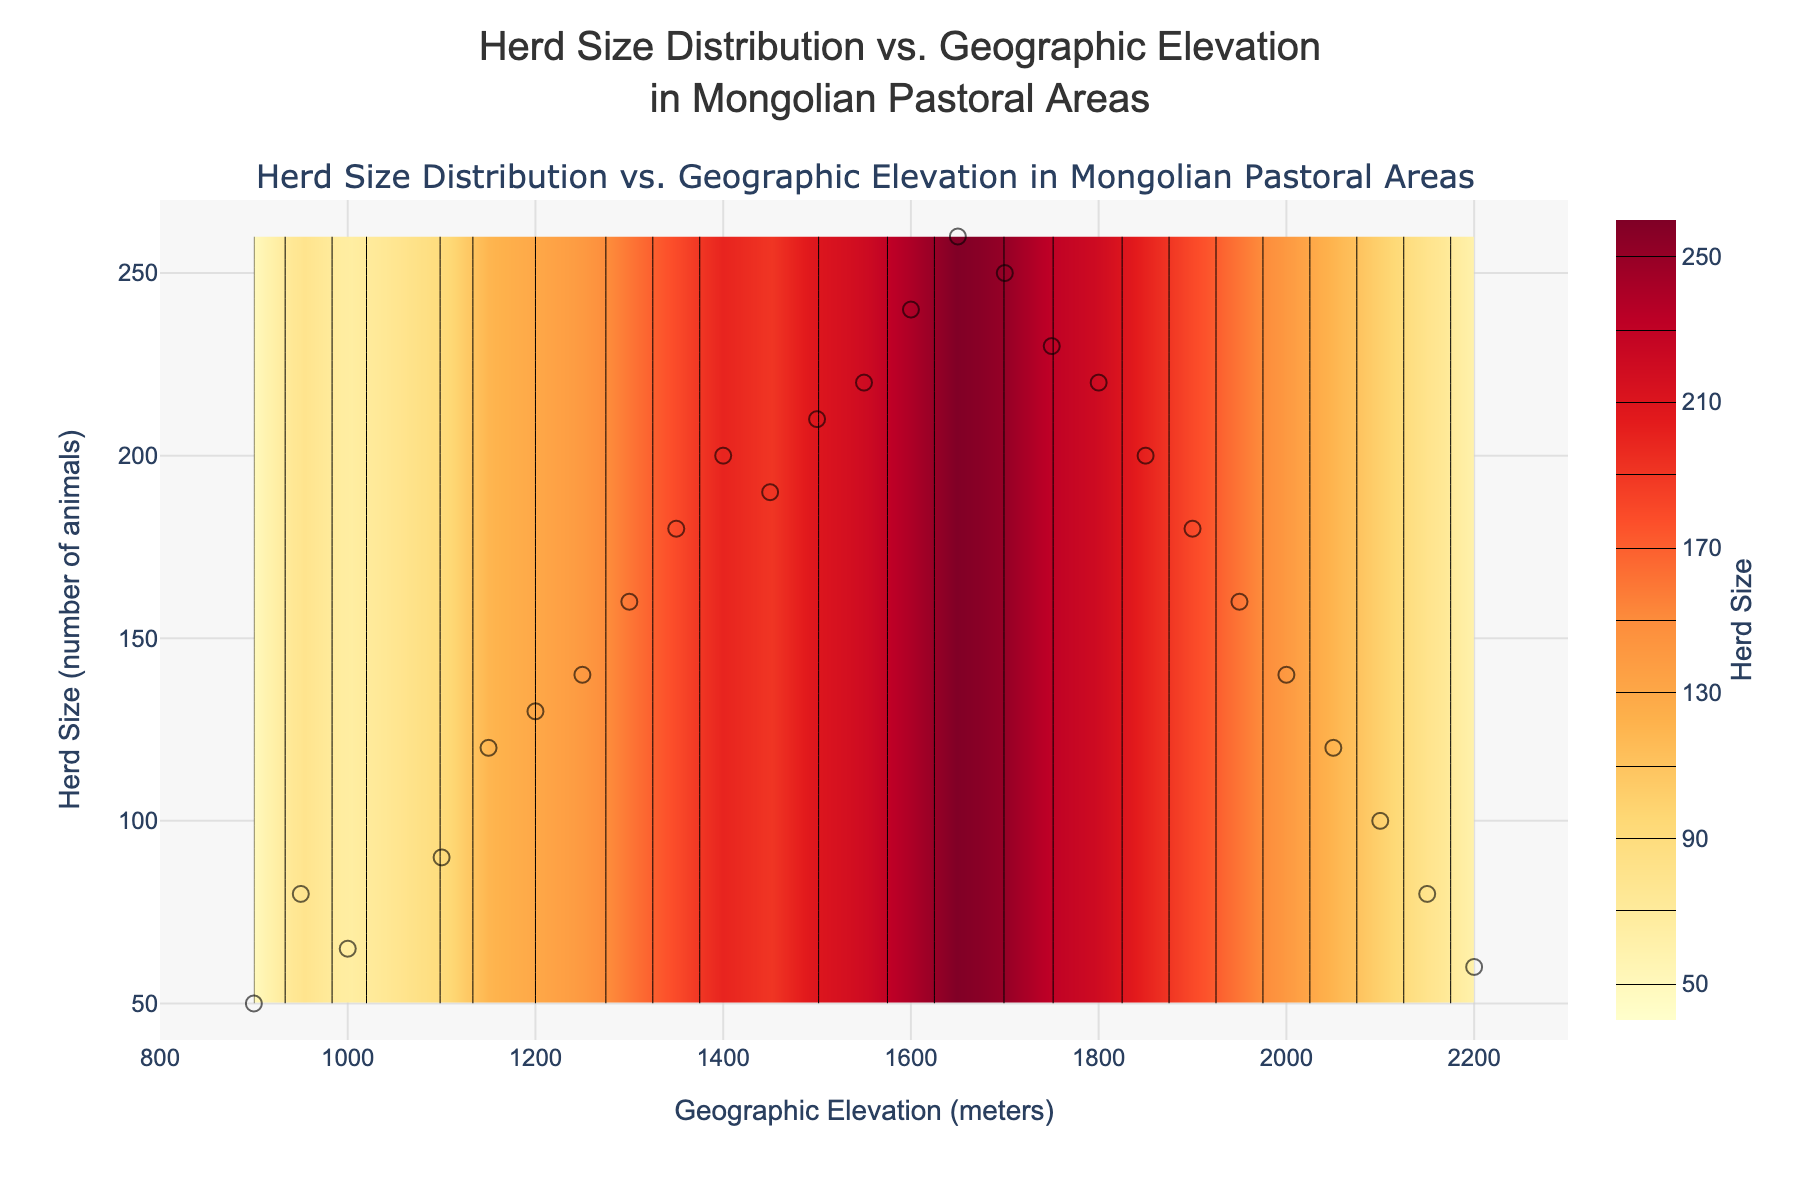What's the title of the figure? The title is usually displayed prominently at the top of the figure. In this case, it states "Herd Size Distribution vs. Geographic Elevation in Mongolian Pastoral Areas".
Answer: Herd Size Distribution vs. Geographic Elevation in Mongolian Pastoral Areas What are the x-axis and y-axis representing? The x-axis and y-axis labels indicate what each axis represents. Here, the x-axis represents "Geographic Elevation (meters)", and the y-axis represents "Herd Size (number of animals)".
Answer: x-axis: Geographic Elevation (meters), y-axis: Herd Size (number of animals) How many data points are plotted on the scatter plot? The scatter plot shows each data point as a separate marker. By counting these markers, we find there are 26 data points.
Answer: 26 At what elevation is the herd size at its peak? By examining the contour plot, we see that the highest contour lines representing the peak herd size of 260 animals occur around the elevation of 1650 meters.
Answer: 1650 meters How does the herd size change with increasing elevation? The contour plot shows herd size variations with elevation. Initially, herd size increases with elevation, peaks around 1650 meters, and then begins to decrease as elevation continues to rise.
Answer: Increases, peaks, then decreases What is the color used to represent the highest herd size in the contour plot? The color scale indicates that the highest herd size is represented by the darkest red color in the YlOrRd color scale.
Answer: Darkest red Compare the herd size at 900 meters and 1800 meters elevation. Observing the scatter plot and contour lines, we see that at 900 meters, the herd size is about 50 animals, whereas at 1800 meters, it is around 220 animals.
Answer: 50 at 900 meters, 220 at 1800 meters Which elevation range shows the most variation in herd size? By examining the contour density and scatter plot distribution, we see that the most variation occurs between 1200 and 1700 meters, indicated by the wide range of contour lines and data points.
Answer: 1200-1700 meters What is the average herd size between 1300 and 1500 meters? First, identify the herd sizes at 1300 meters (160) and 1500 meters (210). The average is calculated as (160 + 210) / 2.
Answer: 185 Is there a clear pattern in the herd size distribution as altitude increases? The contour plot and scatter plot reveal a clear pattern where the herd size increases to a peak at mid-elevations and then decreases as the elevation continues to rise.
Answer: Yes 